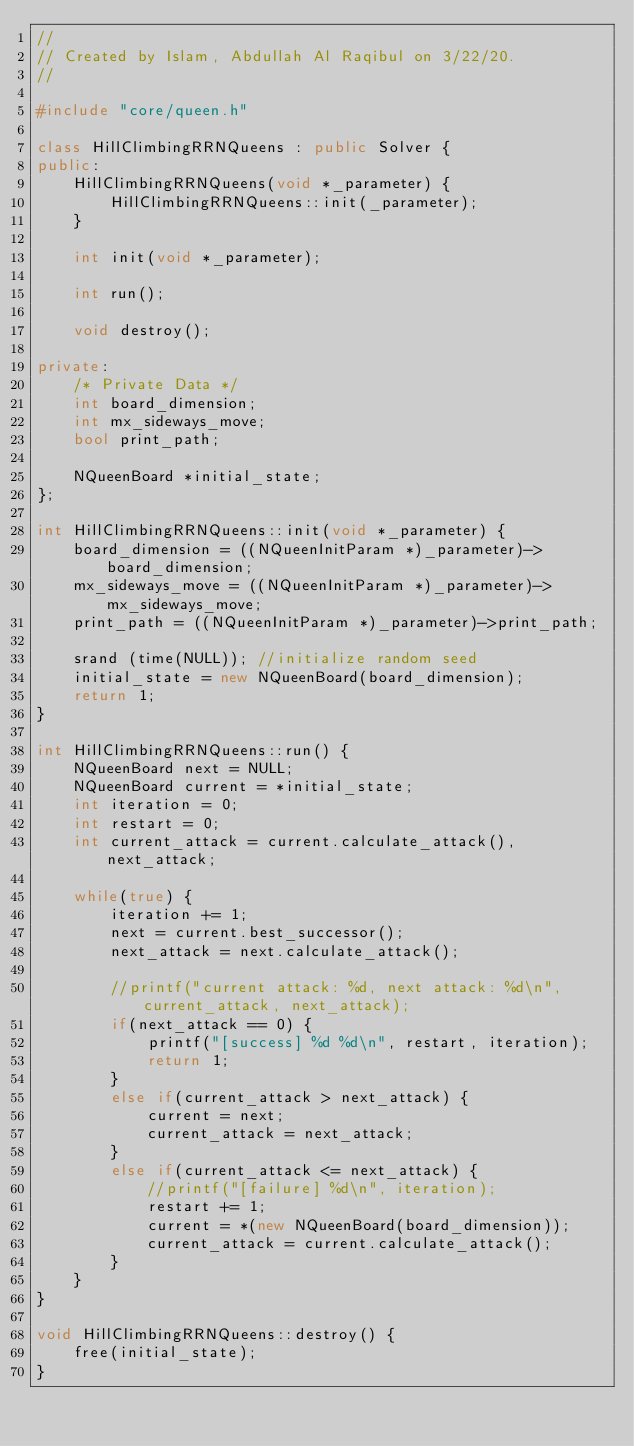<code> <loc_0><loc_0><loc_500><loc_500><_C++_>//
// Created by Islam, Abdullah Al Raqibul on 3/22/20.
//

#include "core/queen.h"

class HillClimbingRRNQueens : public Solver {
public:
    HillClimbingRRNQueens(void *_parameter) {
        HillClimbingRRNQueens::init(_parameter);
    }

    int init(void *_parameter);

    int run();

    void destroy();

private:
    /* Private Data */
    int board_dimension;
    int mx_sideways_move;
    bool print_path;

    NQueenBoard *initial_state;
};

int HillClimbingRRNQueens::init(void *_parameter) {
    board_dimension = ((NQueenInitParam *)_parameter)->board_dimension;
    mx_sideways_move = ((NQueenInitParam *)_parameter)->mx_sideways_move;
    print_path = ((NQueenInitParam *)_parameter)->print_path;

    srand (time(NULL)); //initialize random seed
    initial_state = new NQueenBoard(board_dimension);
    return 1;
}

int HillClimbingRRNQueens::run() {
    NQueenBoard next = NULL;
    NQueenBoard current = *initial_state;
    int iteration = 0;
    int restart = 0;
    int current_attack = current.calculate_attack(), next_attack;

    while(true) {
        iteration += 1;
        next = current.best_successor();
        next_attack = next.calculate_attack();

        //printf("current attack: %d, next attack: %d\n", current_attack, next_attack);
        if(next_attack == 0) {
            printf("[success] %d %d\n", restart, iteration);
            return 1;
        }
        else if(current_attack > next_attack) {
            current = next;
            current_attack = next_attack;
        }
        else if(current_attack <= next_attack) {
            //printf("[failure] %d\n", iteration);
            restart += 1;
            current = *(new NQueenBoard(board_dimension));
            current_attack = current.calculate_attack();
        }
    }
}

void HillClimbingRRNQueens::destroy() {
    free(initial_state);
}</code> 